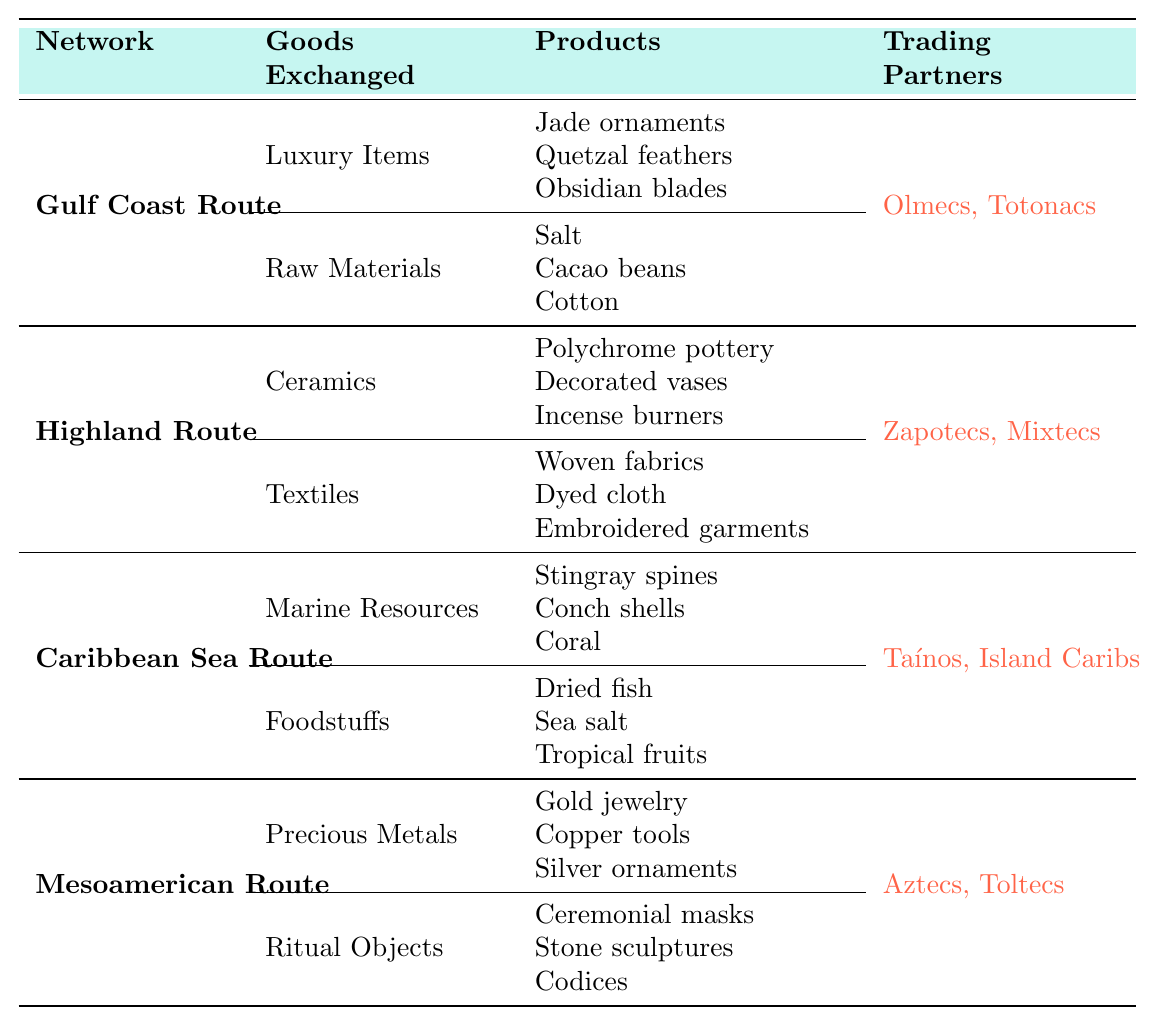What are the luxury items traded along the Gulf Coast Route? The table lists the Gulf Coast Route under the "Network" column. The "Goods Exchanged" for this route includes a category called "Luxury Items." Under that category, the specific products listed are "Jade ornaments," "Quetzal feathers," and "Obsidian blades."
Answer: Jade ornaments, Quetzal feathers, Obsidian blades Which trading partners are associated with the Highland Route? Referring to the Highland Route in the table, we look at the "Trading Partners" column and see that it lists "Zapotecs" and "Mixtecs" as the partners.
Answer: Zapotecs, Mixtecs Count the total number of goods exchanged on the Caribbean Sea Route. For the Caribbean Sea Route, we identify there are two categories of goods exchanged: Marine Resources and Foodstuffs. Each category lists three specific products. Therefore, the total is 3 (Marine Resources) + 3 (Foodstuffs) = 6.
Answer: 6 Are ceremonial masks listed as a product exchanged in the Mesoamerican Route? We check the Mesoamerican Route section in the table. Under "Ritual Objects," "Ceremonial masks" are indeed listed as a product, confirming that they are part of the goods exchanged.
Answer: Yes What type of products do the Aztecs and Toltecs trade with the Maya? Looking at the Mesoamerican Route in the table, we see that it lists "Precious Metals" and "Ritual Objects" as the types of goods exchanged. Therefore, the products traded with the Maya include Gold jewelry, Copper tools, Silver ornaments, Ceremonial masks, Stone sculptures, and Codices.
Answer: Precious Metals and Ritual Objects Identify one raw material exchanged on the Gulf Coast Route. Under the Gulf Coast Route and in the "Raw Materials" category, we see "Salt," "Cacao beans," and "Cotton." Any of these is a correct answer, but we can select one, such as "Salt."
Answer: Salt Which route involves trading with the Taínos and Island Caribs? In the table, the Caribbean Sea Route is explicitly stated to be associated with the trading partners "Taínos" and "Island Caribs" exactly, providing a clear answer.
Answer: Caribbean Sea Route If we sum the number of products from the Highland Route and the Mesoamerican Route, what is the total? The Highland Route has 6 products (3 in Ceramics and 3 in Textiles), while the Mesoamerican Route also has 6 products (3 in Precious Metals and 3 in Ritual Objects). Adding these gives 6 + 6 = 12.
Answer: 12 